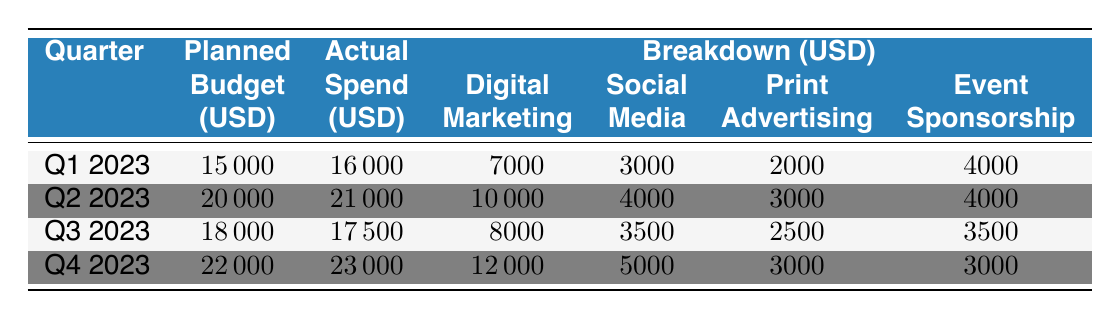What was the actual spend in Q1 2023? The table shows that the actual spend for Q1 2023 is listed under the "Actual" column next to that quarter, which is 16000 USD.
Answer: 16000 How much did the company spend on Digital Marketing in Q2 2023? The breakdown for Q2 2023 shows that Digital Marketing spend is specifically mentioned as 10000 USD.
Answer: 10000 What was the total planned budget for all quarters combined? To find the total planned budget, we sum the values in the "Planned Budget" column: 15000 + 20000 + 18000 + 22000 = 75000 USD.
Answer: 75000 Did the company exceed its planned budget in Q4 2023? The actual spend for Q4 2023 is 23000 USD, while the planned budget was 22000 USD, indicating the actual spend exceeded the plan.
Answer: Yes What was the average actual spend across all four quarters? The actual spends for all quarters are 16000, 21000, 17500, and 23000. To find the average: (16000 + 21000 + 17500 + 23000) / 4 = 19375 USD.
Answer: 19375 In which quarter was the highest actual spend recorded? Looking at the "Actual" column, the highest spend is 23000 USD, which occurs in Q4 2023.
Answer: Q4 2023 What is the difference between the planned budget and actual spend in Q3 2023? The planned budget for Q3 2023 is 18000 USD and the actual spend is 17500 USD. The difference is calculated as 18000 - 17500 = 500 USD.
Answer: 500 Was the amount spent on Social Media higher in Q1 2023 than in Q3 2023? The amount spent on Social Media in Q1 2023 is 3000 USD, while in Q3 2023 it is 3500 USD. Since 3500 > 3000, the statement is false.
Answer: No What percentage of the planned budget was actually spent in Q2 2023? The actual spend for Q2 2023 is 21000 USD with a planned budget of 20000 USD. The percentage is calculated as (21000/20000) * 100 = 105%.
Answer: 105% 